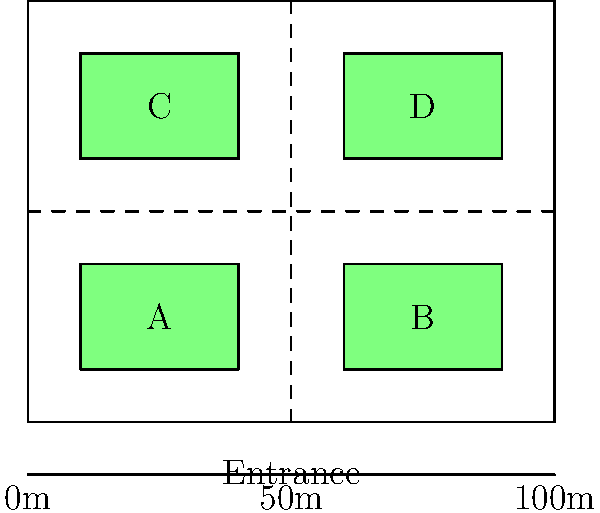Given the floor plan of a converted warehouse for a vintage car showroom, which layout configuration would likely maximize visitor flow and car visibility? Consider that areas A, B, C, and D can each hold up to 5 vintage cars, and the dashed lines represent main walkways. To determine the optimal layout for maximizing visitor flow and car visibility, we need to consider several factors:

1. Entrance location: The entrance is centrally located at the bottom of the floor plan, which is ideal for visitor distribution.

2. Walkway configuration: The dashed lines form a cross-shaped main walkway, dividing the showroom into four quadrants (A, B, C, and D).

3. Car placement areas: Each quadrant can hold up to 5 vintage cars.

4. Visitor flow: The layout should encourage a natural flow of visitors through all areas of the showroom.

5. Car visibility: Cars should be placed to maximize their visibility from the walkways.

Considering these factors, the optimal layout would be:

a) Place the most attractive or valuable vintage cars in areas A and B (nearest to the entrance) to immediately capture visitors' attention.

b) Distribute cars evenly across all four areas to encourage exploration of the entire showroom.

c) Arrange cars within each area at slight angles facing the walkways to improve visibility.

d) Use area C for a rotating display or special exhibition to draw visitors to the back of the showroom.

e) Utilize area D for a lounge or information area, providing a natural endpoint for the visitor journey.

This layout maximizes visitor flow by creating a natural path from the entrance, through areas A and B, to the back of the showroom (C and D), and then returning to the exit. It also ensures that cars in all areas are visible from the main walkways, enhancing the overall viewing experience.
Answer: Evenly distributed cars across A, B, C, D; prime cars in A, B; special exhibit in C; lounge in D. 